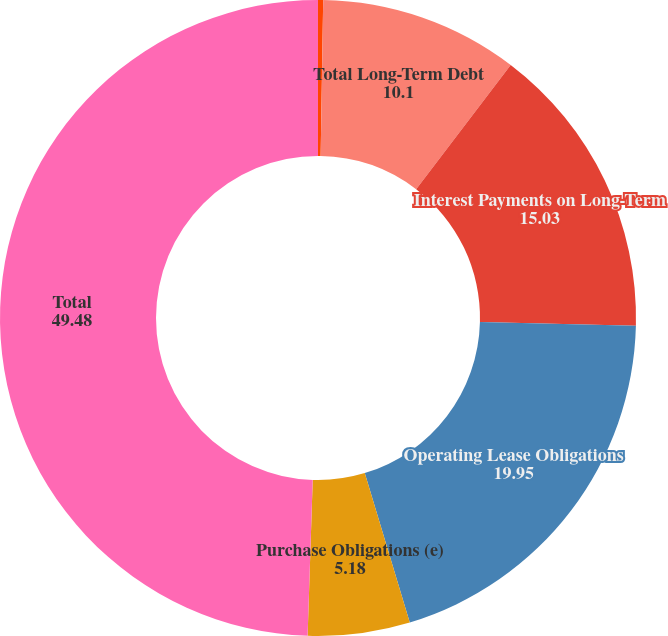<chart> <loc_0><loc_0><loc_500><loc_500><pie_chart><fcel>Capital Lease Obligations (b)<fcel>Total Long-Term Debt<fcel>Interest Payments on Long-Term<fcel>Operating Lease Obligations<fcel>Purchase Obligations (e)<fcel>Total<nl><fcel>0.26%<fcel>10.1%<fcel>15.03%<fcel>19.95%<fcel>5.18%<fcel>49.48%<nl></chart> 